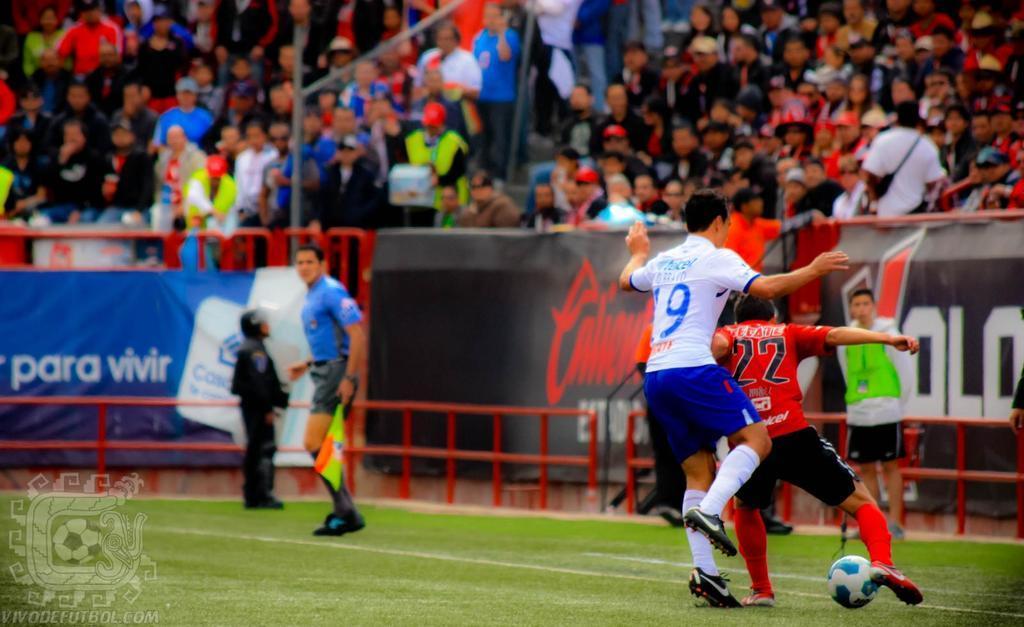How would you summarize this image in a sentence or two? In this image i can see few persons playing a foot ball at the back ground i can see a banner and few persons are sitting and standing. 